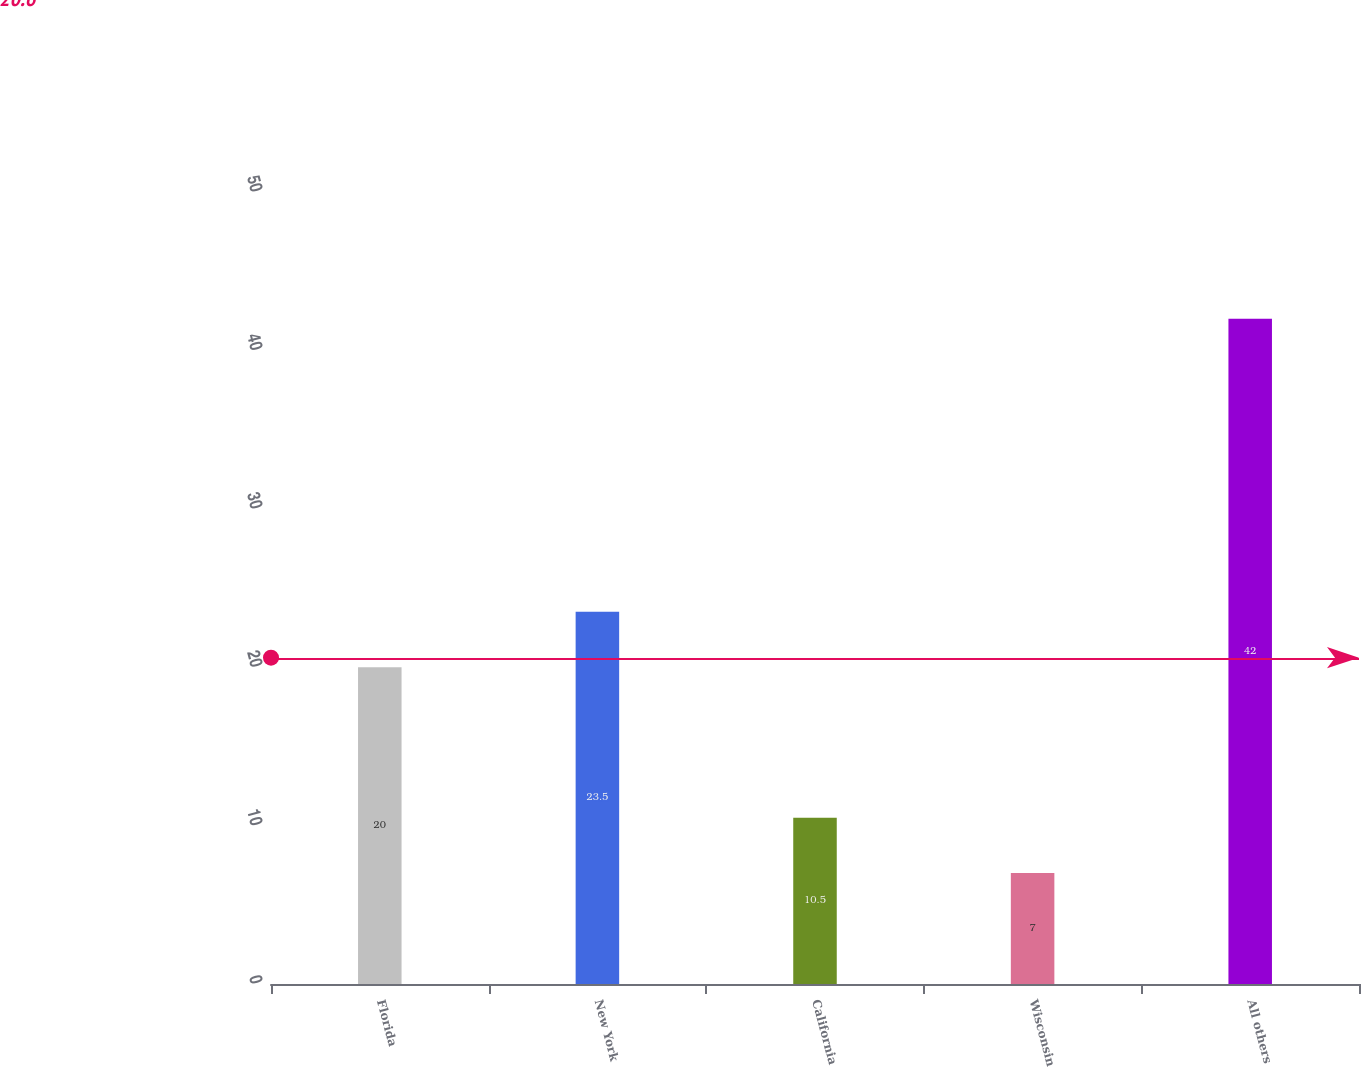<chart> <loc_0><loc_0><loc_500><loc_500><bar_chart><fcel>Florida<fcel>New York<fcel>California<fcel>Wisconsin<fcel>All others<nl><fcel>20<fcel>23.5<fcel>10.5<fcel>7<fcel>42<nl></chart> 